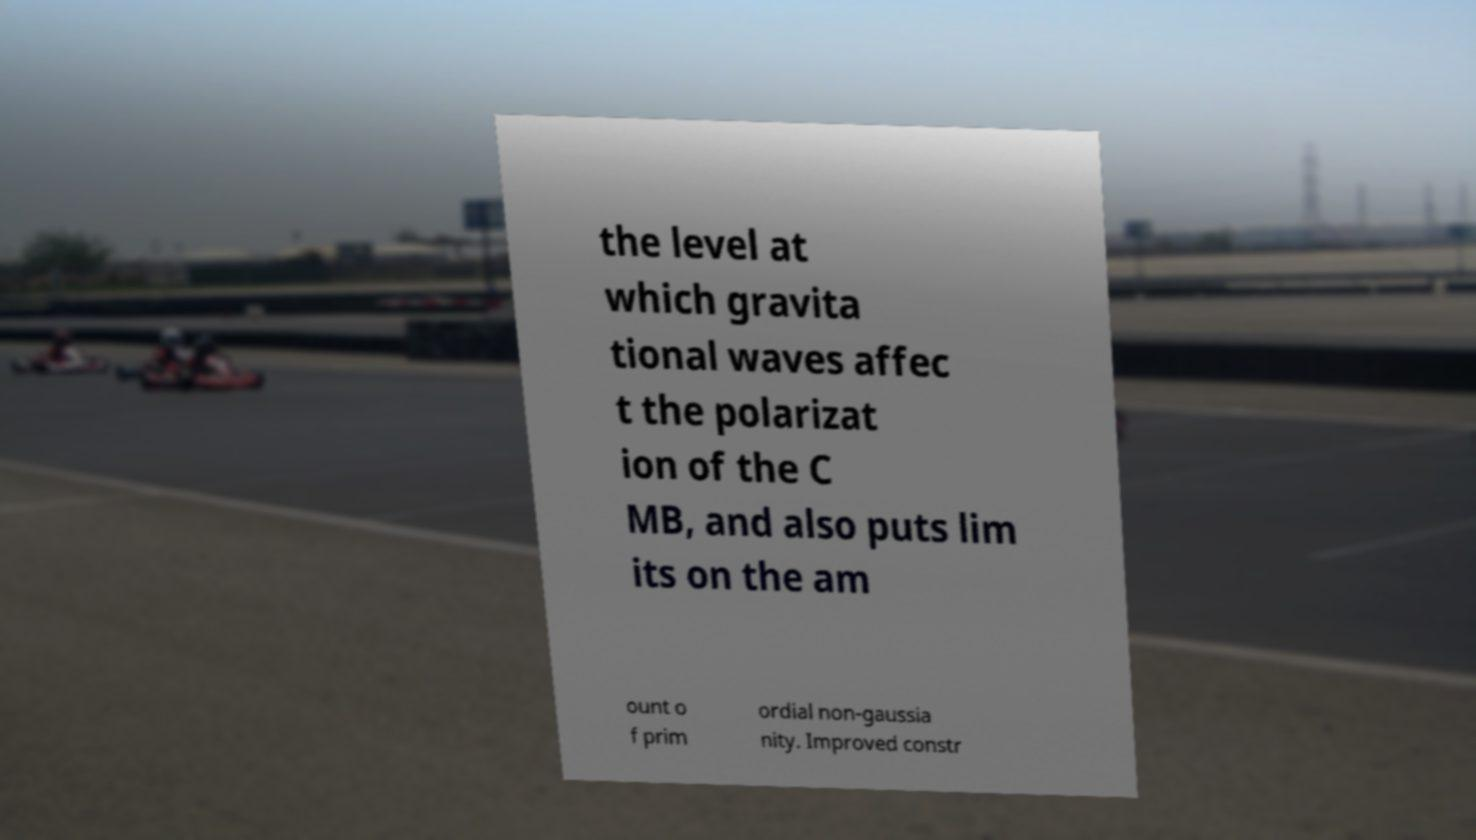Could you extract and type out the text from this image? the level at which gravita tional waves affec t the polarizat ion of the C MB, and also puts lim its on the am ount o f prim ordial non-gaussia nity. Improved constr 